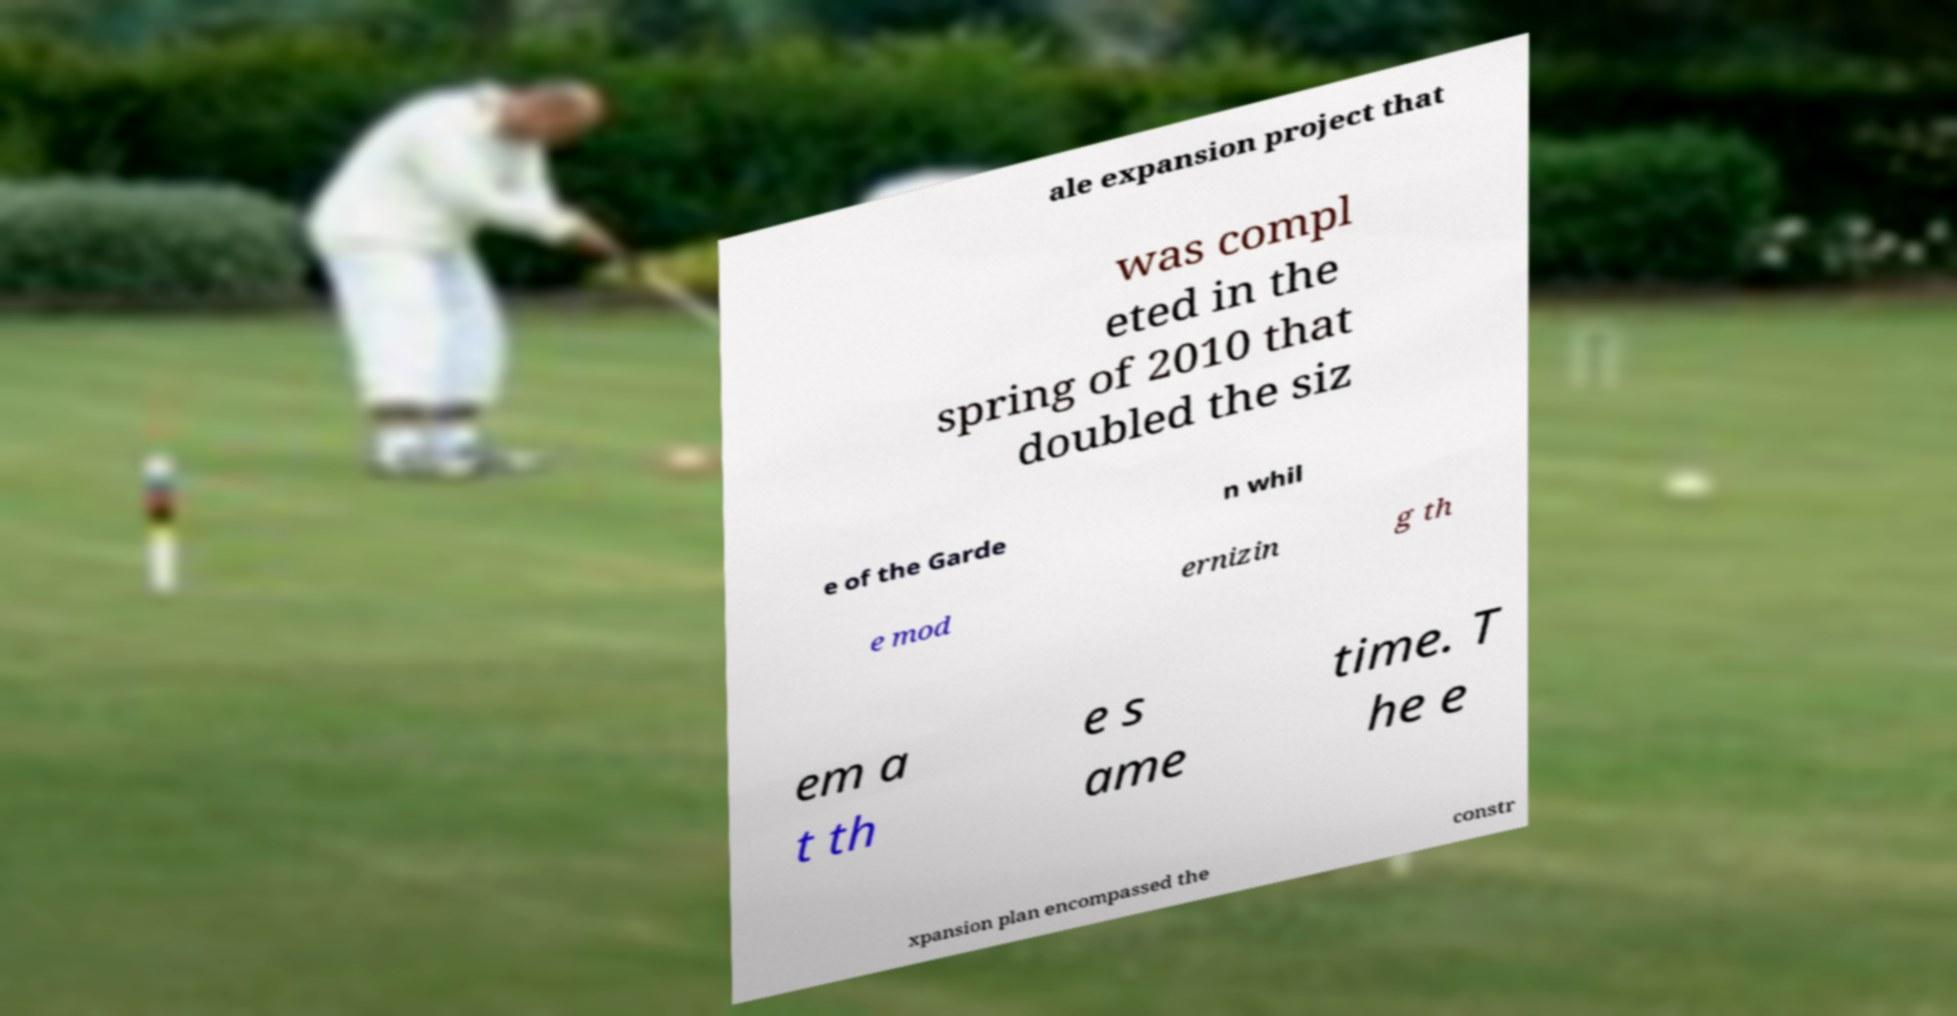Can you read and provide the text displayed in the image?This photo seems to have some interesting text. Can you extract and type it out for me? ale expansion project that was compl eted in the spring of 2010 that doubled the siz e of the Garde n whil e mod ernizin g th em a t th e s ame time. T he e xpansion plan encompassed the constr 